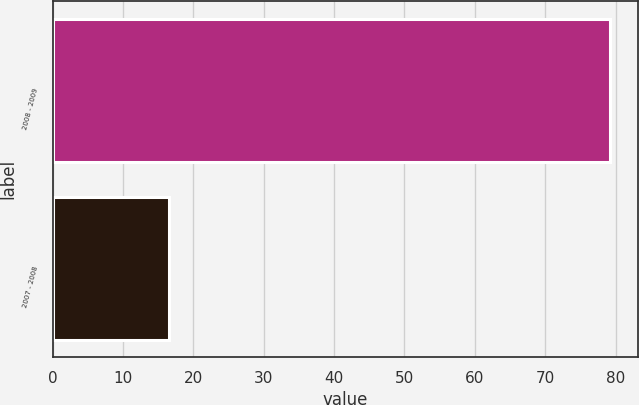<chart> <loc_0><loc_0><loc_500><loc_500><bar_chart><fcel>2008 - 2009<fcel>2007 - 2008<nl><fcel>79.2<fcel>16.5<nl></chart> 